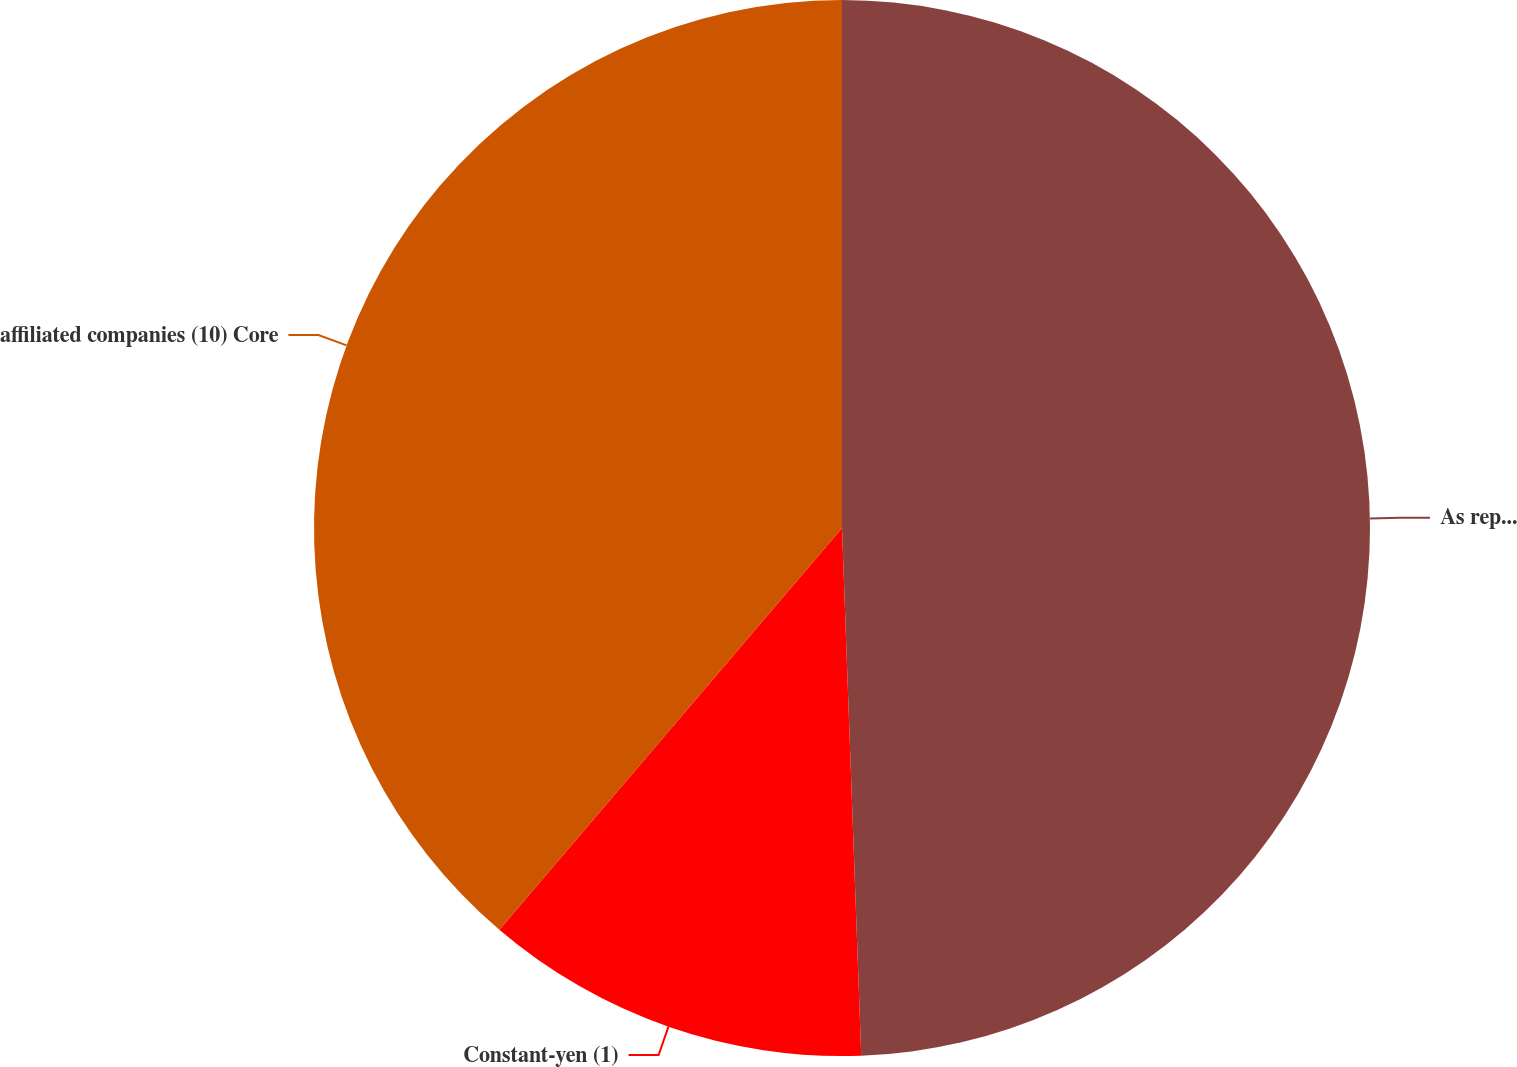<chart> <loc_0><loc_0><loc_500><loc_500><pie_chart><fcel>As reported<fcel>Constant-yen (1)<fcel>affiliated companies (10) Core<nl><fcel>49.42%<fcel>11.82%<fcel>38.76%<nl></chart> 